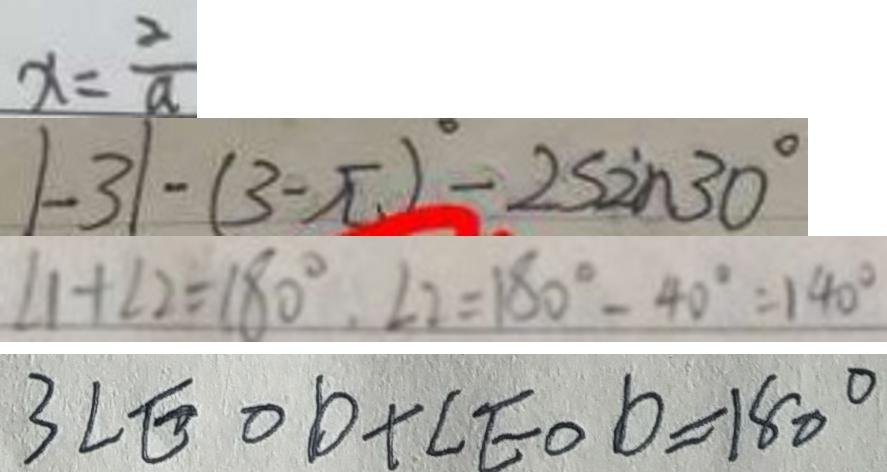Convert formula to latex. <formula><loc_0><loc_0><loc_500><loc_500>x = \frac { 2 } { a } 
 \vert - 3 \vert - ( 3 - \pi ) ^ { \circ } - 2 \sin 3 0 ^ { \circ } 
 \angle 1 + \angle 2 = 1 8 0 ^ { \circ } , \angle 2 = 1 8 0 ^ { \circ } - 4 0 ^ { \circ } = 1 4 0 ^ { \circ } 
 3 \angle E O D + \angle E O D = 1 8 0 ^ { \circ }</formula> 